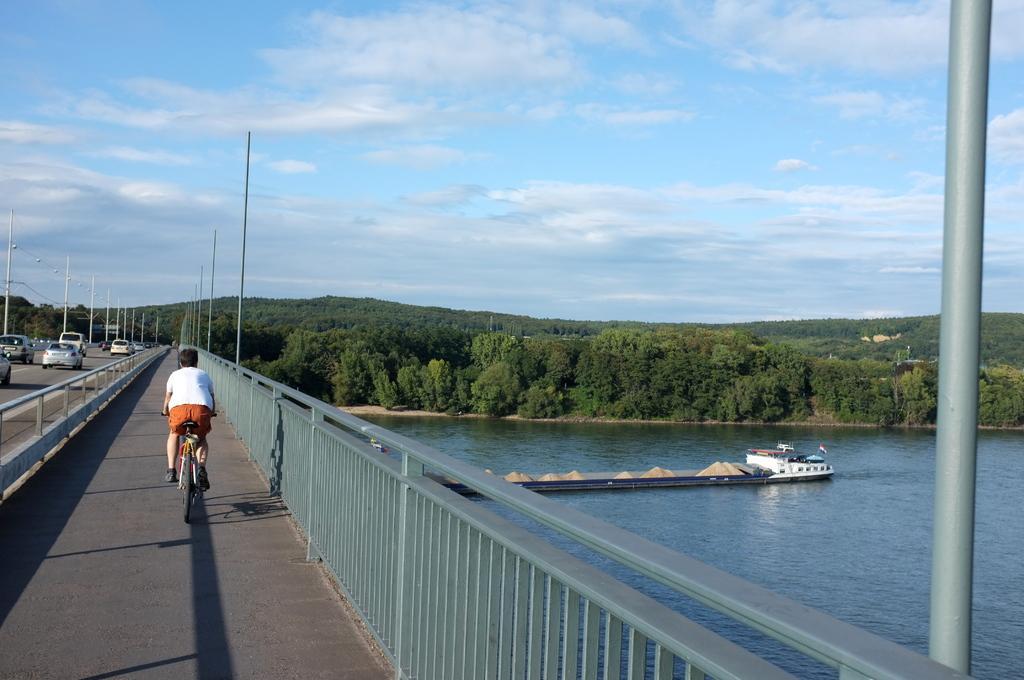Describe this image in one or two sentences. This image is taken outdoors. At the top of the image there is a sky with clouds. In the background there are many trees and plants. On the left side of the image there is a bridge with railings and many cars are moving on the road. A boy is riding a bicycle on the road and there are many poles. On the right side of the image there is a river with water and there is a boat on the river. 